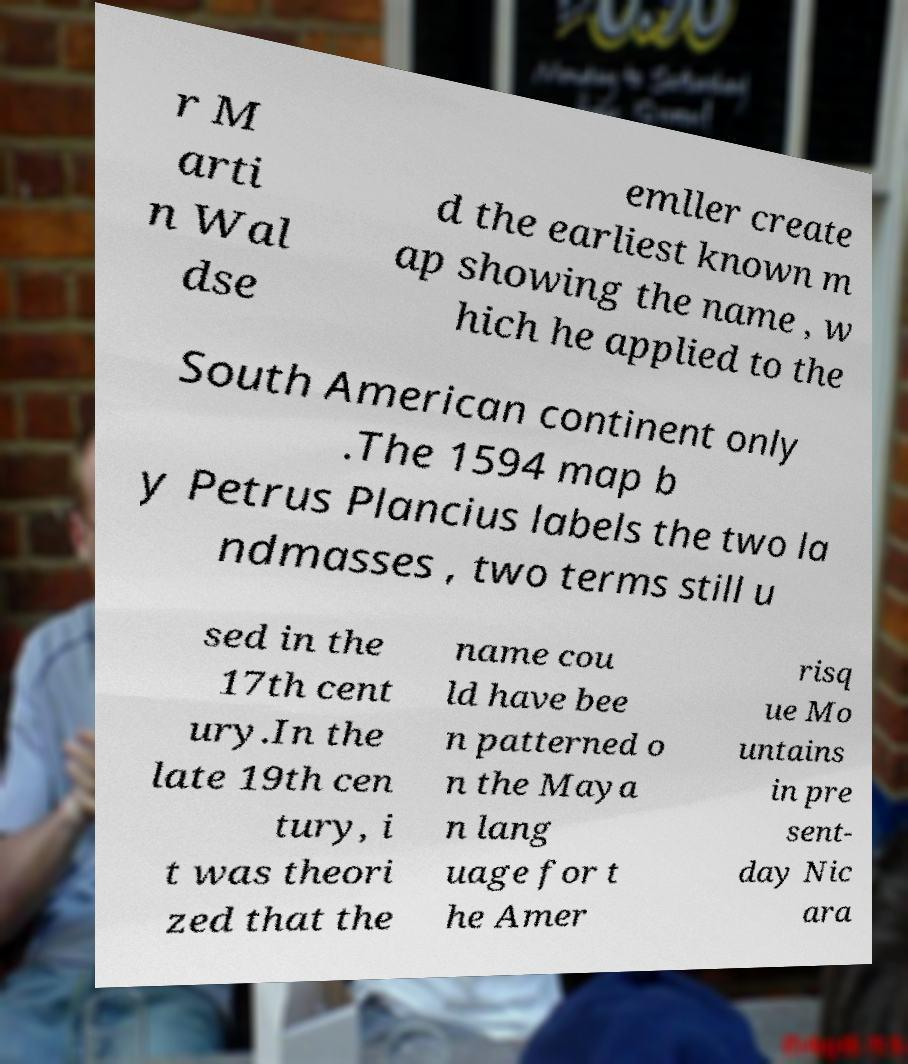There's text embedded in this image that I need extracted. Can you transcribe it verbatim? r M arti n Wal dse emller create d the earliest known m ap showing the name , w hich he applied to the South American continent only .The 1594 map b y Petrus Plancius labels the two la ndmasses , two terms still u sed in the 17th cent ury.In the late 19th cen tury, i t was theori zed that the name cou ld have bee n patterned o n the Maya n lang uage for t he Amer risq ue Mo untains in pre sent- day Nic ara 